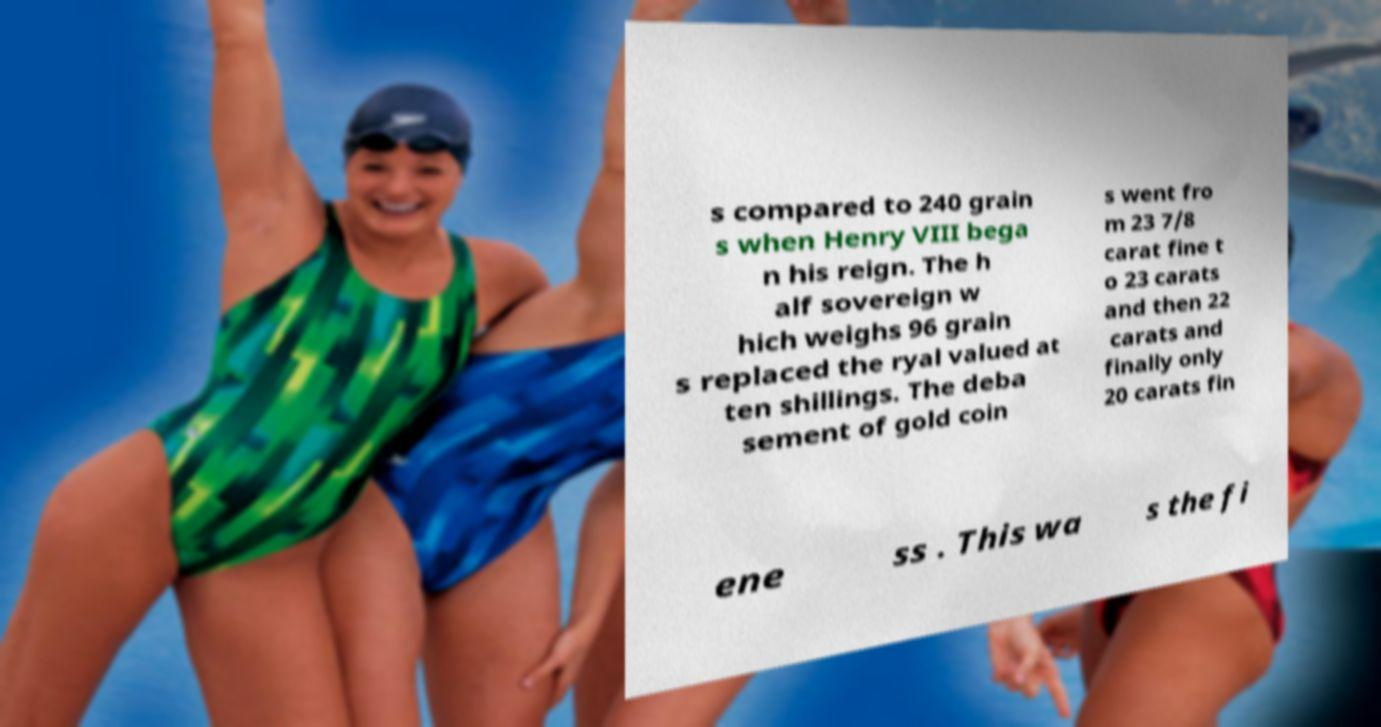Could you extract and type out the text from this image? s compared to 240 grain s when Henry VIII bega n his reign. The h alf sovereign w hich weighs 96 grain s replaced the ryal valued at ten shillings. The deba sement of gold coin s went fro m 23 7/8 carat fine t o 23 carats and then 22 carats and finally only 20 carats fin ene ss . This wa s the fi 